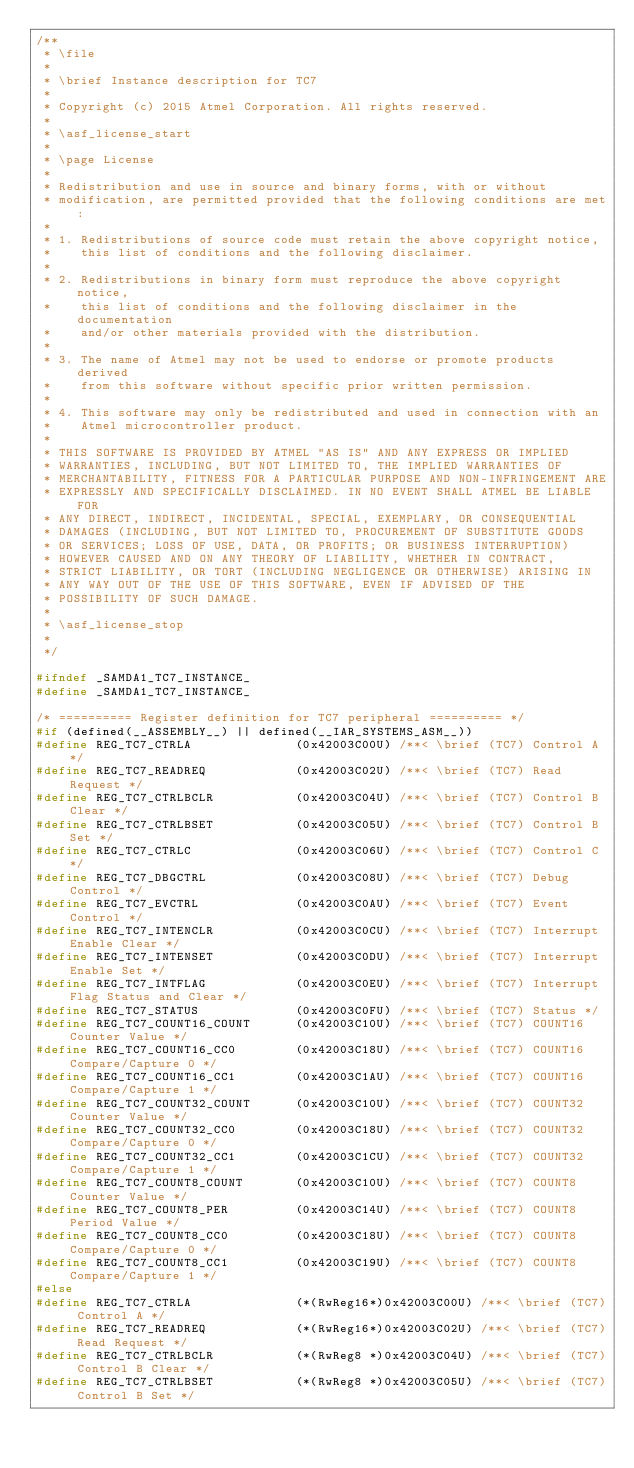Convert code to text. <code><loc_0><loc_0><loc_500><loc_500><_C_>/**
 * \file
 *
 * \brief Instance description for TC7
 *
 * Copyright (c) 2015 Atmel Corporation. All rights reserved.
 *
 * \asf_license_start
 *
 * \page License
 *
 * Redistribution and use in source and binary forms, with or without
 * modification, are permitted provided that the following conditions are met:
 *
 * 1. Redistributions of source code must retain the above copyright notice,
 *    this list of conditions and the following disclaimer.
 *
 * 2. Redistributions in binary form must reproduce the above copyright notice,
 *    this list of conditions and the following disclaimer in the documentation
 *    and/or other materials provided with the distribution.
 *
 * 3. The name of Atmel may not be used to endorse or promote products derived
 *    from this software without specific prior written permission.
 *
 * 4. This software may only be redistributed and used in connection with an
 *    Atmel microcontroller product.
 *
 * THIS SOFTWARE IS PROVIDED BY ATMEL "AS IS" AND ANY EXPRESS OR IMPLIED
 * WARRANTIES, INCLUDING, BUT NOT LIMITED TO, THE IMPLIED WARRANTIES OF
 * MERCHANTABILITY, FITNESS FOR A PARTICULAR PURPOSE AND NON-INFRINGEMENT ARE
 * EXPRESSLY AND SPECIFICALLY DISCLAIMED. IN NO EVENT SHALL ATMEL BE LIABLE FOR
 * ANY DIRECT, INDIRECT, INCIDENTAL, SPECIAL, EXEMPLARY, OR CONSEQUENTIAL
 * DAMAGES (INCLUDING, BUT NOT LIMITED TO, PROCUREMENT OF SUBSTITUTE GOODS
 * OR SERVICES; LOSS OF USE, DATA, OR PROFITS; OR BUSINESS INTERRUPTION)
 * HOWEVER CAUSED AND ON ANY THEORY OF LIABILITY, WHETHER IN CONTRACT,
 * STRICT LIABILITY, OR TORT (INCLUDING NEGLIGENCE OR OTHERWISE) ARISING IN
 * ANY WAY OUT OF THE USE OF THIS SOFTWARE, EVEN IF ADVISED OF THE
 * POSSIBILITY OF SUCH DAMAGE.
 *
 * \asf_license_stop
 *
 */

#ifndef _SAMDA1_TC7_INSTANCE_
#define _SAMDA1_TC7_INSTANCE_

/* ========== Register definition for TC7 peripheral ========== */
#if (defined(__ASSEMBLY__) || defined(__IAR_SYSTEMS_ASM__))
#define REG_TC7_CTRLA              (0x42003C00U) /**< \brief (TC7) Control A */
#define REG_TC7_READREQ            (0x42003C02U) /**< \brief (TC7) Read Request */
#define REG_TC7_CTRLBCLR           (0x42003C04U) /**< \brief (TC7) Control B Clear */
#define REG_TC7_CTRLBSET           (0x42003C05U) /**< \brief (TC7) Control B Set */
#define REG_TC7_CTRLC              (0x42003C06U) /**< \brief (TC7) Control C */
#define REG_TC7_DBGCTRL            (0x42003C08U) /**< \brief (TC7) Debug Control */
#define REG_TC7_EVCTRL             (0x42003C0AU) /**< \brief (TC7) Event Control */
#define REG_TC7_INTENCLR           (0x42003C0CU) /**< \brief (TC7) Interrupt Enable Clear */
#define REG_TC7_INTENSET           (0x42003C0DU) /**< \brief (TC7) Interrupt Enable Set */
#define REG_TC7_INTFLAG            (0x42003C0EU) /**< \brief (TC7) Interrupt Flag Status and Clear */
#define REG_TC7_STATUS             (0x42003C0FU) /**< \brief (TC7) Status */
#define REG_TC7_COUNT16_COUNT      (0x42003C10U) /**< \brief (TC7) COUNT16 Counter Value */
#define REG_TC7_COUNT16_CC0        (0x42003C18U) /**< \brief (TC7) COUNT16 Compare/Capture 0 */
#define REG_TC7_COUNT16_CC1        (0x42003C1AU) /**< \brief (TC7) COUNT16 Compare/Capture 1 */
#define REG_TC7_COUNT32_COUNT      (0x42003C10U) /**< \brief (TC7) COUNT32 Counter Value */
#define REG_TC7_COUNT32_CC0        (0x42003C18U) /**< \brief (TC7) COUNT32 Compare/Capture 0 */
#define REG_TC7_COUNT32_CC1        (0x42003C1CU) /**< \brief (TC7) COUNT32 Compare/Capture 1 */
#define REG_TC7_COUNT8_COUNT       (0x42003C10U) /**< \brief (TC7) COUNT8 Counter Value */
#define REG_TC7_COUNT8_PER         (0x42003C14U) /**< \brief (TC7) COUNT8 Period Value */
#define REG_TC7_COUNT8_CC0         (0x42003C18U) /**< \brief (TC7) COUNT8 Compare/Capture 0 */
#define REG_TC7_COUNT8_CC1         (0x42003C19U) /**< \brief (TC7) COUNT8 Compare/Capture 1 */
#else
#define REG_TC7_CTRLA              (*(RwReg16*)0x42003C00U) /**< \brief (TC7) Control A */
#define REG_TC7_READREQ            (*(RwReg16*)0x42003C02U) /**< \brief (TC7) Read Request */
#define REG_TC7_CTRLBCLR           (*(RwReg8 *)0x42003C04U) /**< \brief (TC7) Control B Clear */
#define REG_TC7_CTRLBSET           (*(RwReg8 *)0x42003C05U) /**< \brief (TC7) Control B Set */</code> 